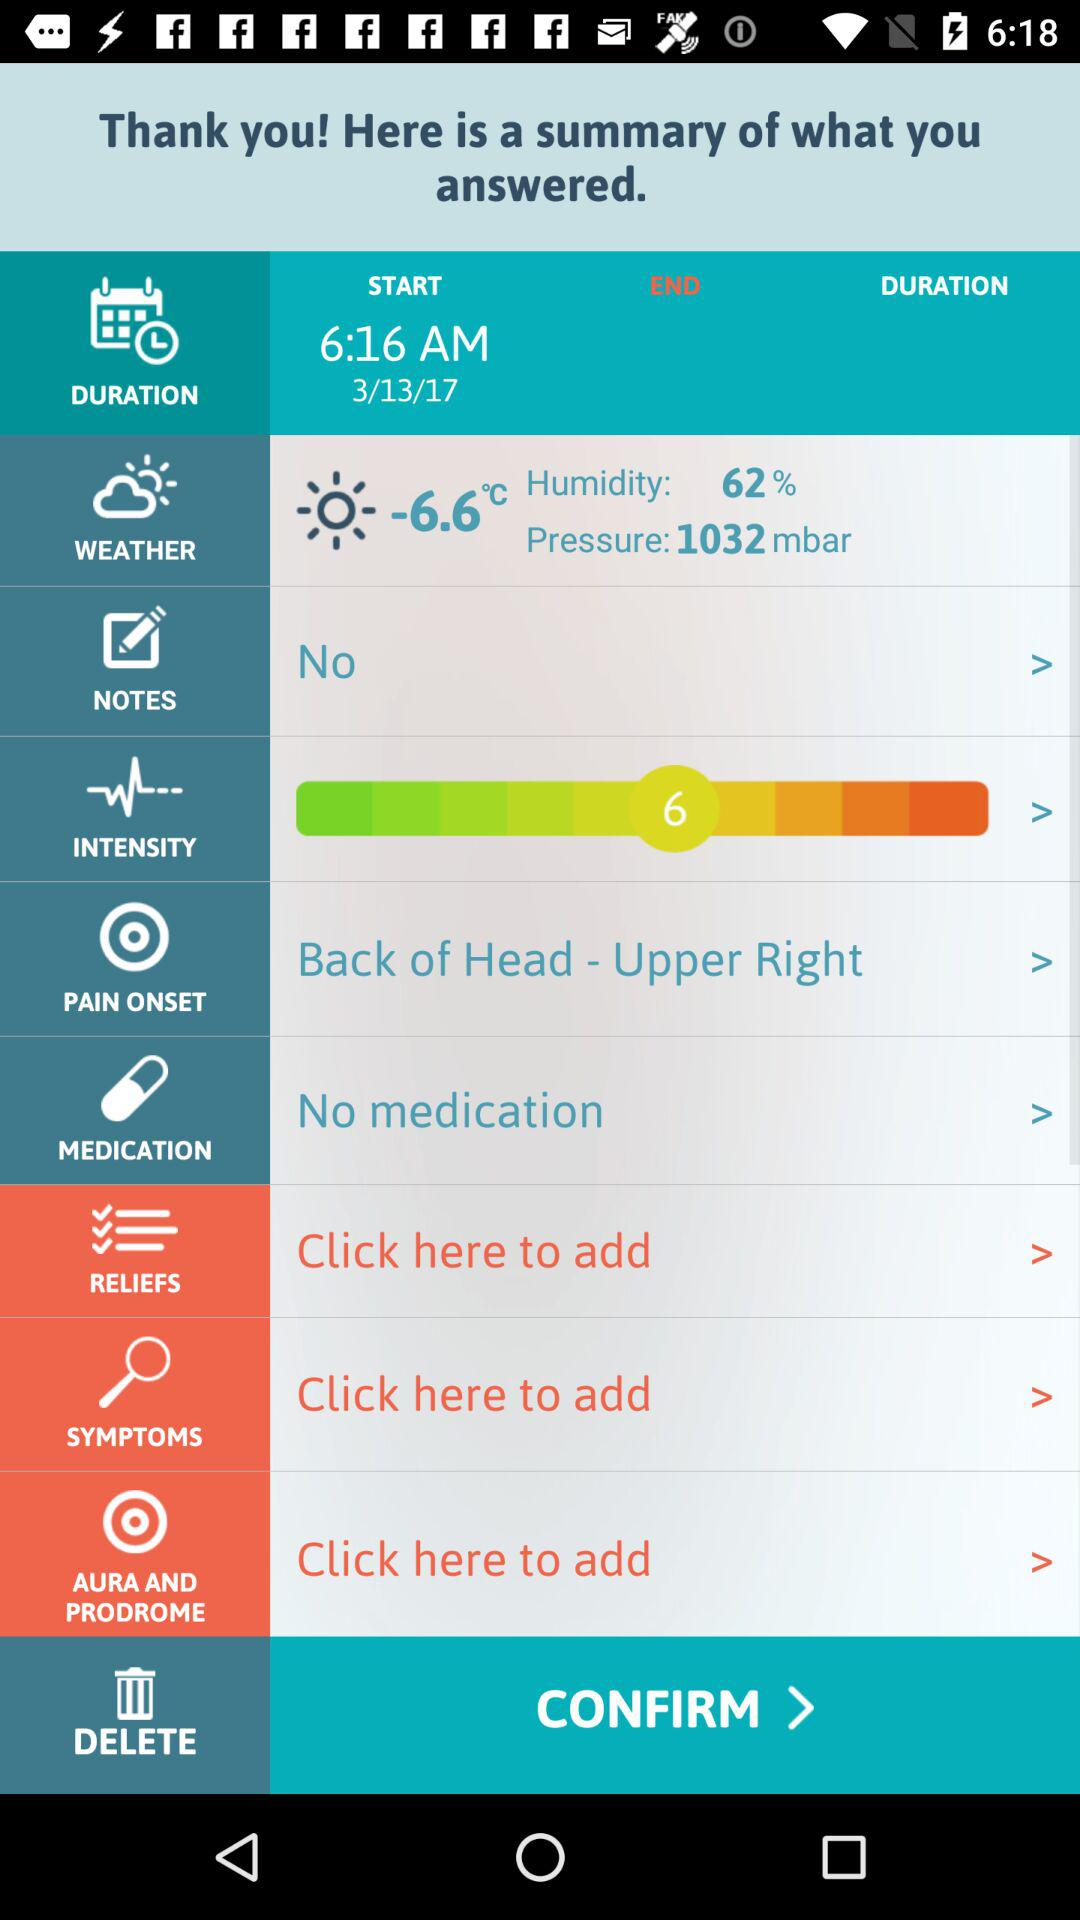What date is given? The given date is March 13, 2017. 